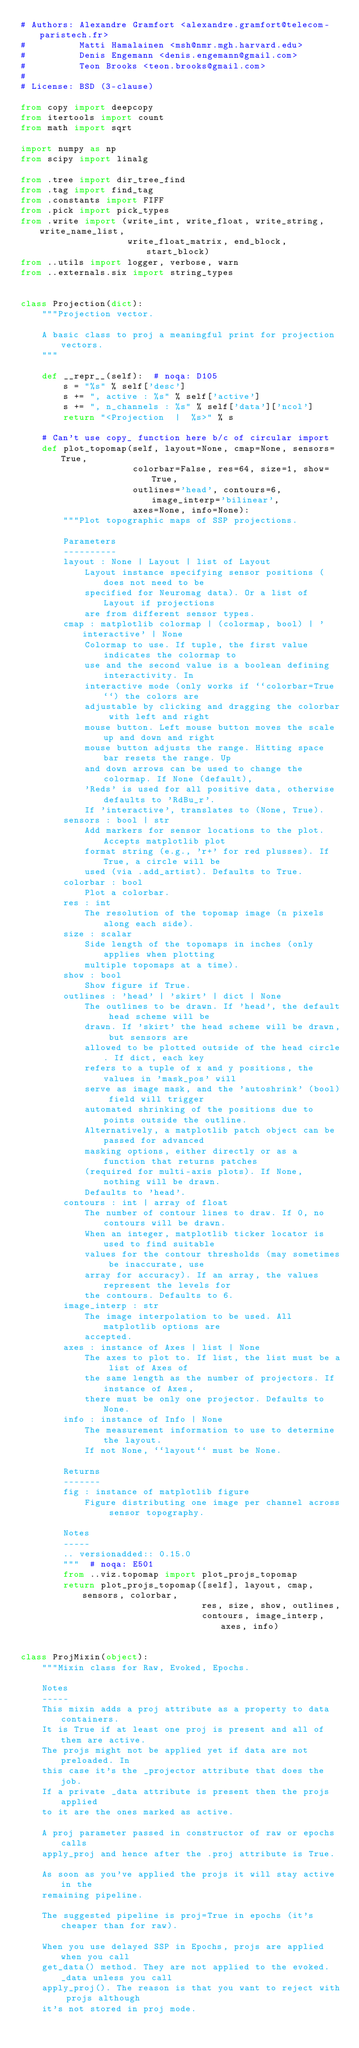<code> <loc_0><loc_0><loc_500><loc_500><_Python_># Authors: Alexandre Gramfort <alexandre.gramfort@telecom-paristech.fr>
#          Matti Hamalainen <msh@nmr.mgh.harvard.edu>
#          Denis Engemann <denis.engemann@gmail.com>
#          Teon Brooks <teon.brooks@gmail.com>
#
# License: BSD (3-clause)

from copy import deepcopy
from itertools import count
from math import sqrt

import numpy as np
from scipy import linalg

from .tree import dir_tree_find
from .tag import find_tag
from .constants import FIFF
from .pick import pick_types
from .write import (write_int, write_float, write_string, write_name_list,
                    write_float_matrix, end_block, start_block)
from ..utils import logger, verbose, warn
from ..externals.six import string_types


class Projection(dict):
    """Projection vector.

    A basic class to proj a meaningful print for projection vectors.
    """

    def __repr__(self):  # noqa: D105
        s = "%s" % self['desc']
        s += ", active : %s" % self['active']
        s += ", n_channels : %s" % self['data']['ncol']
        return "<Projection  |  %s>" % s

    # Can't use copy_ function here b/c of circular import
    def plot_topomap(self, layout=None, cmap=None, sensors=True,
                     colorbar=False, res=64, size=1, show=True,
                     outlines='head', contours=6, image_interp='bilinear',
                     axes=None, info=None):
        """Plot topographic maps of SSP projections.

        Parameters
        ----------
        layout : None | Layout | list of Layout
            Layout instance specifying sensor positions (does not need to be
            specified for Neuromag data). Or a list of Layout if projections
            are from different sensor types.
        cmap : matplotlib colormap | (colormap, bool) | 'interactive' | None
            Colormap to use. If tuple, the first value indicates the colormap to
            use and the second value is a boolean defining interactivity. In
            interactive mode (only works if ``colorbar=True``) the colors are
            adjustable by clicking and dragging the colorbar with left and right
            mouse button. Left mouse button moves the scale up and down and right
            mouse button adjusts the range. Hitting space bar resets the range. Up
            and down arrows can be used to change the colormap. If None (default),
            'Reds' is used for all positive data, otherwise defaults to 'RdBu_r'.
            If 'interactive', translates to (None, True).
        sensors : bool | str
            Add markers for sensor locations to the plot. Accepts matplotlib plot
            format string (e.g., 'r+' for red plusses). If True, a circle will be
            used (via .add_artist). Defaults to True.
        colorbar : bool
            Plot a colorbar.
        res : int
            The resolution of the topomap image (n pixels along each side).
        size : scalar
            Side length of the topomaps in inches (only applies when plotting
            multiple topomaps at a time).
        show : bool
            Show figure if True.
        outlines : 'head' | 'skirt' | dict | None
            The outlines to be drawn. If 'head', the default head scheme will be
            drawn. If 'skirt' the head scheme will be drawn, but sensors are
            allowed to be plotted outside of the head circle. If dict, each key
            refers to a tuple of x and y positions, the values in 'mask_pos' will
            serve as image mask, and the 'autoshrink' (bool) field will trigger
            automated shrinking of the positions due to points outside the outline.
            Alternatively, a matplotlib patch object can be passed for advanced
            masking options, either directly or as a function that returns patches
            (required for multi-axis plots). If None, nothing will be drawn.
            Defaults to 'head'.
        contours : int | array of float
            The number of contour lines to draw. If 0, no contours will be drawn.
            When an integer, matplotlib ticker locator is used to find suitable
            values for the contour thresholds (may sometimes be inaccurate, use
            array for accuracy). If an array, the values represent the levels for
            the contours. Defaults to 6.
        image_interp : str
            The image interpolation to be used. All matplotlib options are
            accepted.
        axes : instance of Axes | list | None
            The axes to plot to. If list, the list must be a list of Axes of
            the same length as the number of projectors. If instance of Axes,
            there must be only one projector. Defaults to None.
        info : instance of Info | None
            The measurement information to use to determine the layout.
            If not None, ``layout`` must be None.

        Returns
        -------
        fig : instance of matplotlib figure
            Figure distributing one image per channel across sensor topography.

        Notes
        -----
        .. versionadded:: 0.15.0
        """  # noqa: E501
        from ..viz.topomap import plot_projs_topomap
        return plot_projs_topomap([self], layout, cmap, sensors, colorbar,
                                  res, size, show, outlines,
                                  contours, image_interp, axes, info)


class ProjMixin(object):
    """Mixin class for Raw, Evoked, Epochs.

    Notes
    -----
    This mixin adds a proj attribute as a property to data containers.
    It is True if at least one proj is present and all of them are active.
    The projs might not be applied yet if data are not preloaded. In
    this case it's the _projector attribute that does the job.
    If a private _data attribute is present then the projs applied
    to it are the ones marked as active.

    A proj parameter passed in constructor of raw or epochs calls
    apply_proj and hence after the .proj attribute is True.

    As soon as you've applied the projs it will stay active in the
    remaining pipeline.

    The suggested pipeline is proj=True in epochs (it's cheaper than for raw).

    When you use delayed SSP in Epochs, projs are applied when you call
    get_data() method. They are not applied to the evoked._data unless you call
    apply_proj(). The reason is that you want to reject with projs although
    it's not stored in proj mode.</code> 